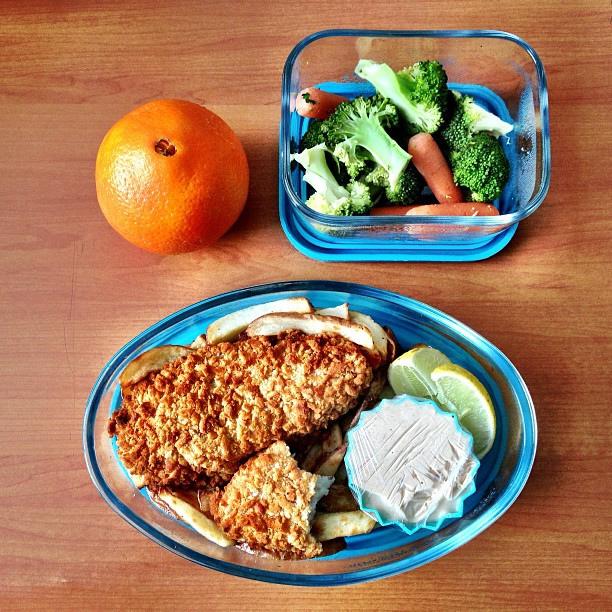What is the green food?
Short answer required. Broccoli. What is in the small blue ramekin?
Keep it brief. Vegetables. Could that be a navel orange?
Short answer required. Yes. 